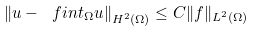<formula> <loc_0><loc_0><loc_500><loc_500>\left \| u - \ f i n t _ { \Omega } u \right \| _ { H ^ { 2 } ( \Omega ) } \leq C \| f \| _ { L ^ { 2 } ( \Omega ) }</formula> 